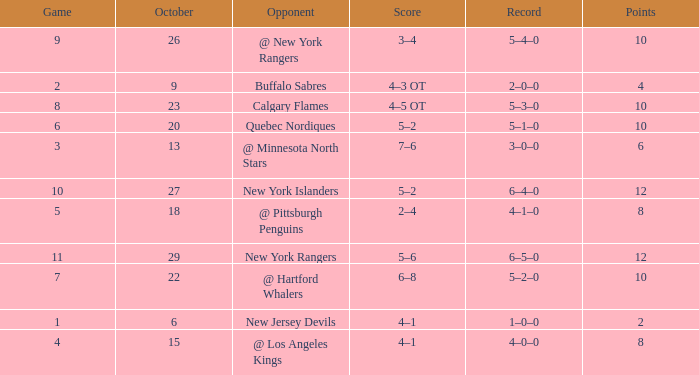Which October has a Record of 5–1–0, and a Game larger than 6? None. 